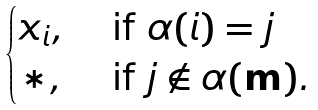<formula> <loc_0><loc_0><loc_500><loc_500>\begin{cases} x _ { i } , & \text { if } \alpha ( i ) = j \\ * , & \text { if } j \notin \alpha ( \mathbf m ) . \end{cases}</formula> 